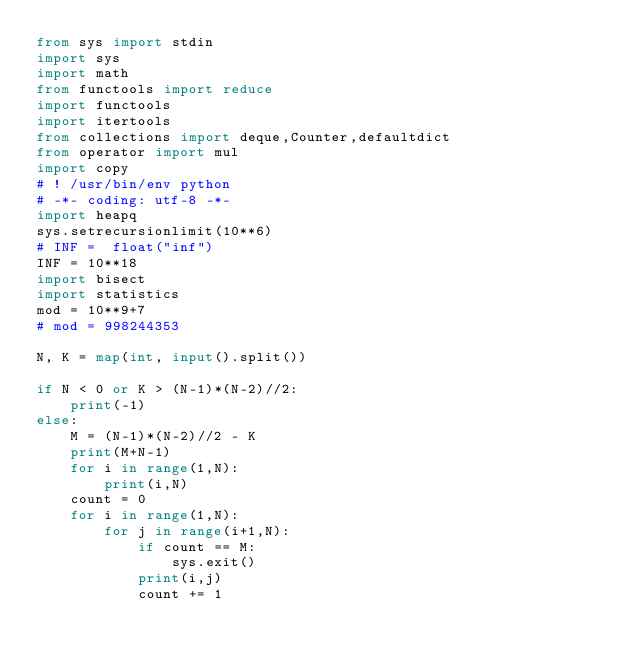<code> <loc_0><loc_0><loc_500><loc_500><_Python_>from sys import stdin
import sys
import math
from functools import reduce
import functools
import itertools
from collections import deque,Counter,defaultdict
from operator import mul
import copy
# ! /usr/bin/env python
# -*- coding: utf-8 -*-
import heapq
sys.setrecursionlimit(10**6)
# INF =  float("inf")
INF = 10**18
import bisect
import statistics
mod = 10**9+7
# mod = 998244353

N, K = map(int, input().split())

if N < 0 or K > (N-1)*(N-2)//2:
    print(-1)
else:
    M = (N-1)*(N-2)//2 - K
    print(M+N-1)
    for i in range(1,N):
        print(i,N)
    count = 0
    for i in range(1,N):
        for j in range(i+1,N):
            if count == M:
                sys.exit()
            print(i,j)
            count += 1
</code> 